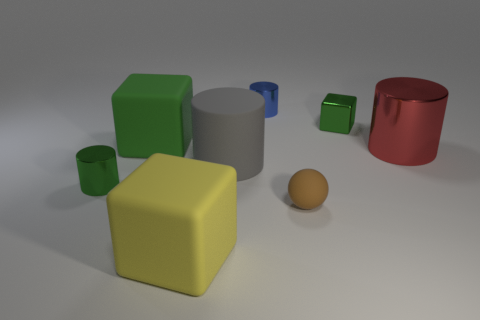Subtract all big rubber cylinders. How many cylinders are left? 3 Add 2 brown things. How many objects exist? 10 Subtract all gray cylinders. How many cylinders are left? 3 Subtract 2 cubes. How many cubes are left? 1 Subtract all gray blocks. Subtract all blue cylinders. How many blocks are left? 3 Subtract all yellow cubes. How many red cylinders are left? 1 Subtract all gray rubber things. Subtract all large yellow matte objects. How many objects are left? 6 Add 5 gray matte objects. How many gray matte objects are left? 6 Add 7 tiny brown rubber spheres. How many tiny brown rubber spheres exist? 8 Subtract 0 green balls. How many objects are left? 8 